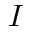<formula> <loc_0><loc_0><loc_500><loc_500>I</formula> 